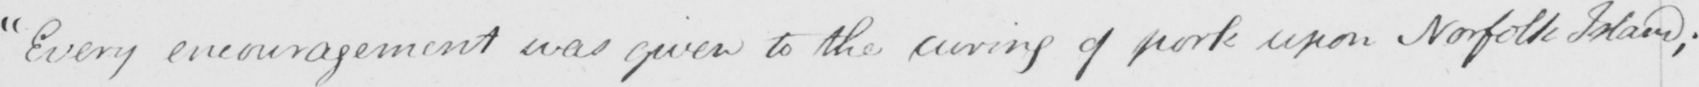What text is written in this handwritten line? Every encouragement was given to the curing of pork upon Norfolk Island ; 